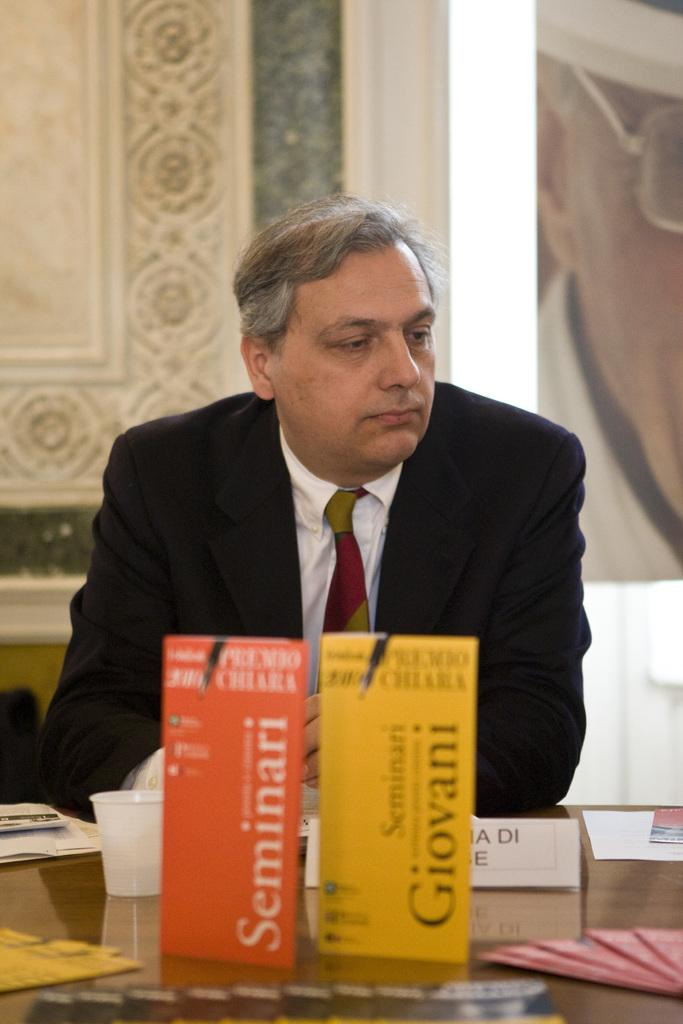What is the main subject of the image? There is a person in the image. What is located in front of the person? There is a group of objects on a surface in front of the person. What can be seen behind the person? There is a wall visible in the image. What is on the wall? There is a poster on the wall in the image. Is there any blood visible on the person or the objects in the image? No, there is no blood visible in the image. What historical event is depicted in the poster on the wall? The provided facts do not mention any historical event or context related to the poster, so it cannot be determined from the image. 